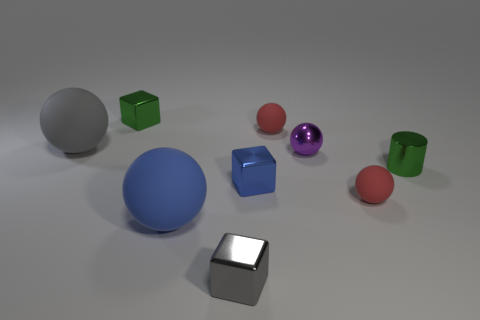There is a blue object that is left of the gray metallic object; how many blue blocks are to the right of it?
Offer a very short reply. 1. What number of yellow things are either large matte things or rubber balls?
Keep it short and to the point. 0. The small red rubber thing behind the small blue thing left of the red rubber thing that is behind the tiny metallic cylinder is what shape?
Your answer should be compact. Sphere. There is a metal ball that is the same size as the blue block; what is its color?
Keep it short and to the point. Purple. How many other small metallic things are the same shape as the blue metal object?
Give a very brief answer. 2. Is the size of the gray metal object the same as the green thing that is on the left side of the small metallic sphere?
Provide a succinct answer. Yes. The red matte object that is behind the green shiny object on the right side of the big blue object is what shape?
Give a very brief answer. Sphere. Is the number of gray metallic things that are behind the large gray object less than the number of yellow metallic things?
Give a very brief answer. No. The shiny thing that is the same color as the shiny cylinder is what shape?
Your answer should be very brief. Cube. How many red rubber spheres are the same size as the blue metal block?
Offer a very short reply. 2. 